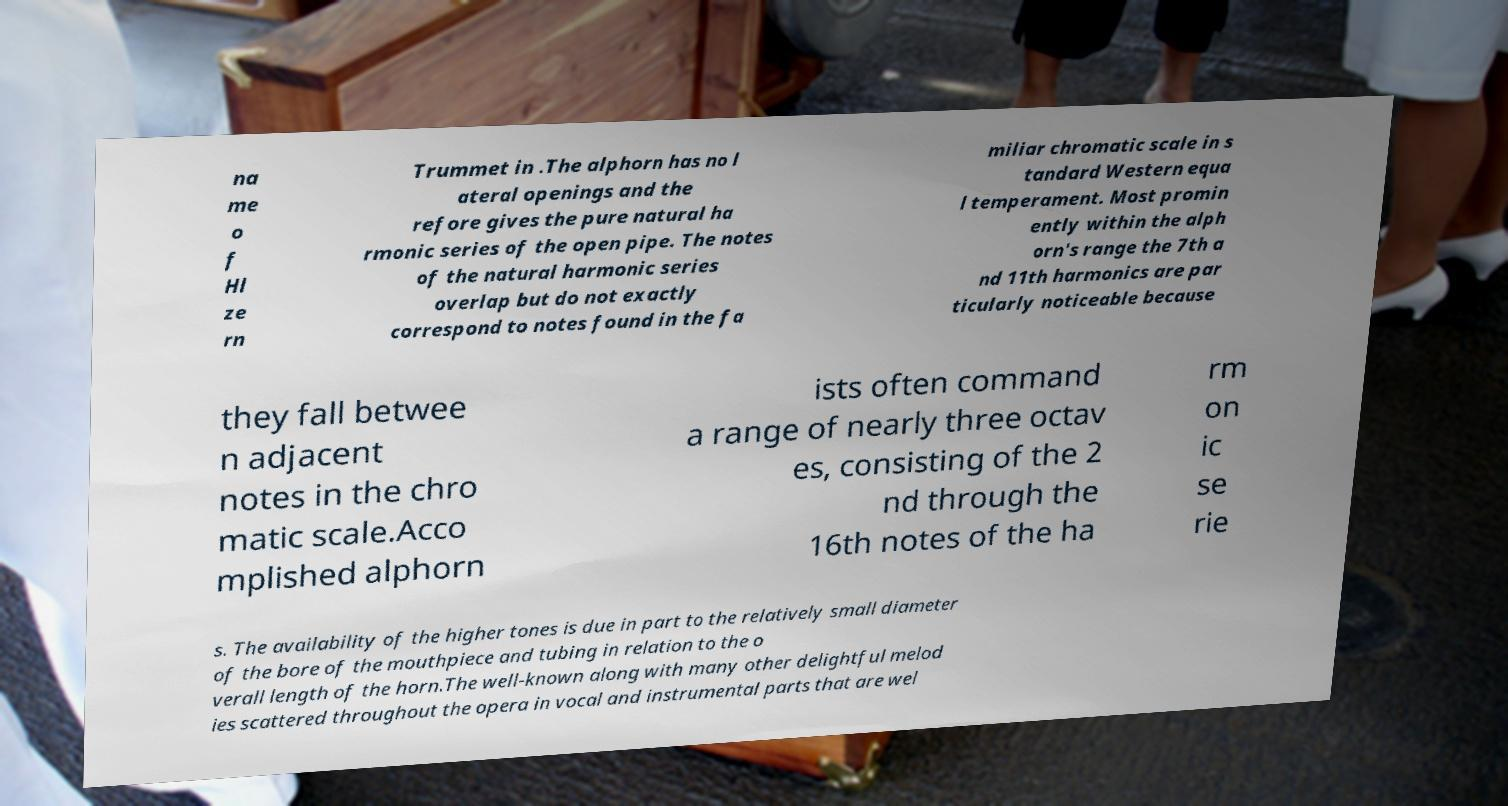Can you read and provide the text displayed in the image?This photo seems to have some interesting text. Can you extract and type it out for me? na me o f Hl ze rn Trummet in .The alphorn has no l ateral openings and the refore gives the pure natural ha rmonic series of the open pipe. The notes of the natural harmonic series overlap but do not exactly correspond to notes found in the fa miliar chromatic scale in s tandard Western equa l temperament. Most promin ently within the alph orn's range the 7th a nd 11th harmonics are par ticularly noticeable because they fall betwee n adjacent notes in the chro matic scale.Acco mplished alphorn ists often command a range of nearly three octav es, consisting of the 2 nd through the 16th notes of the ha rm on ic se rie s. The availability of the higher tones is due in part to the relatively small diameter of the bore of the mouthpiece and tubing in relation to the o verall length of the horn.The well-known along with many other delightful melod ies scattered throughout the opera in vocal and instrumental parts that are wel 